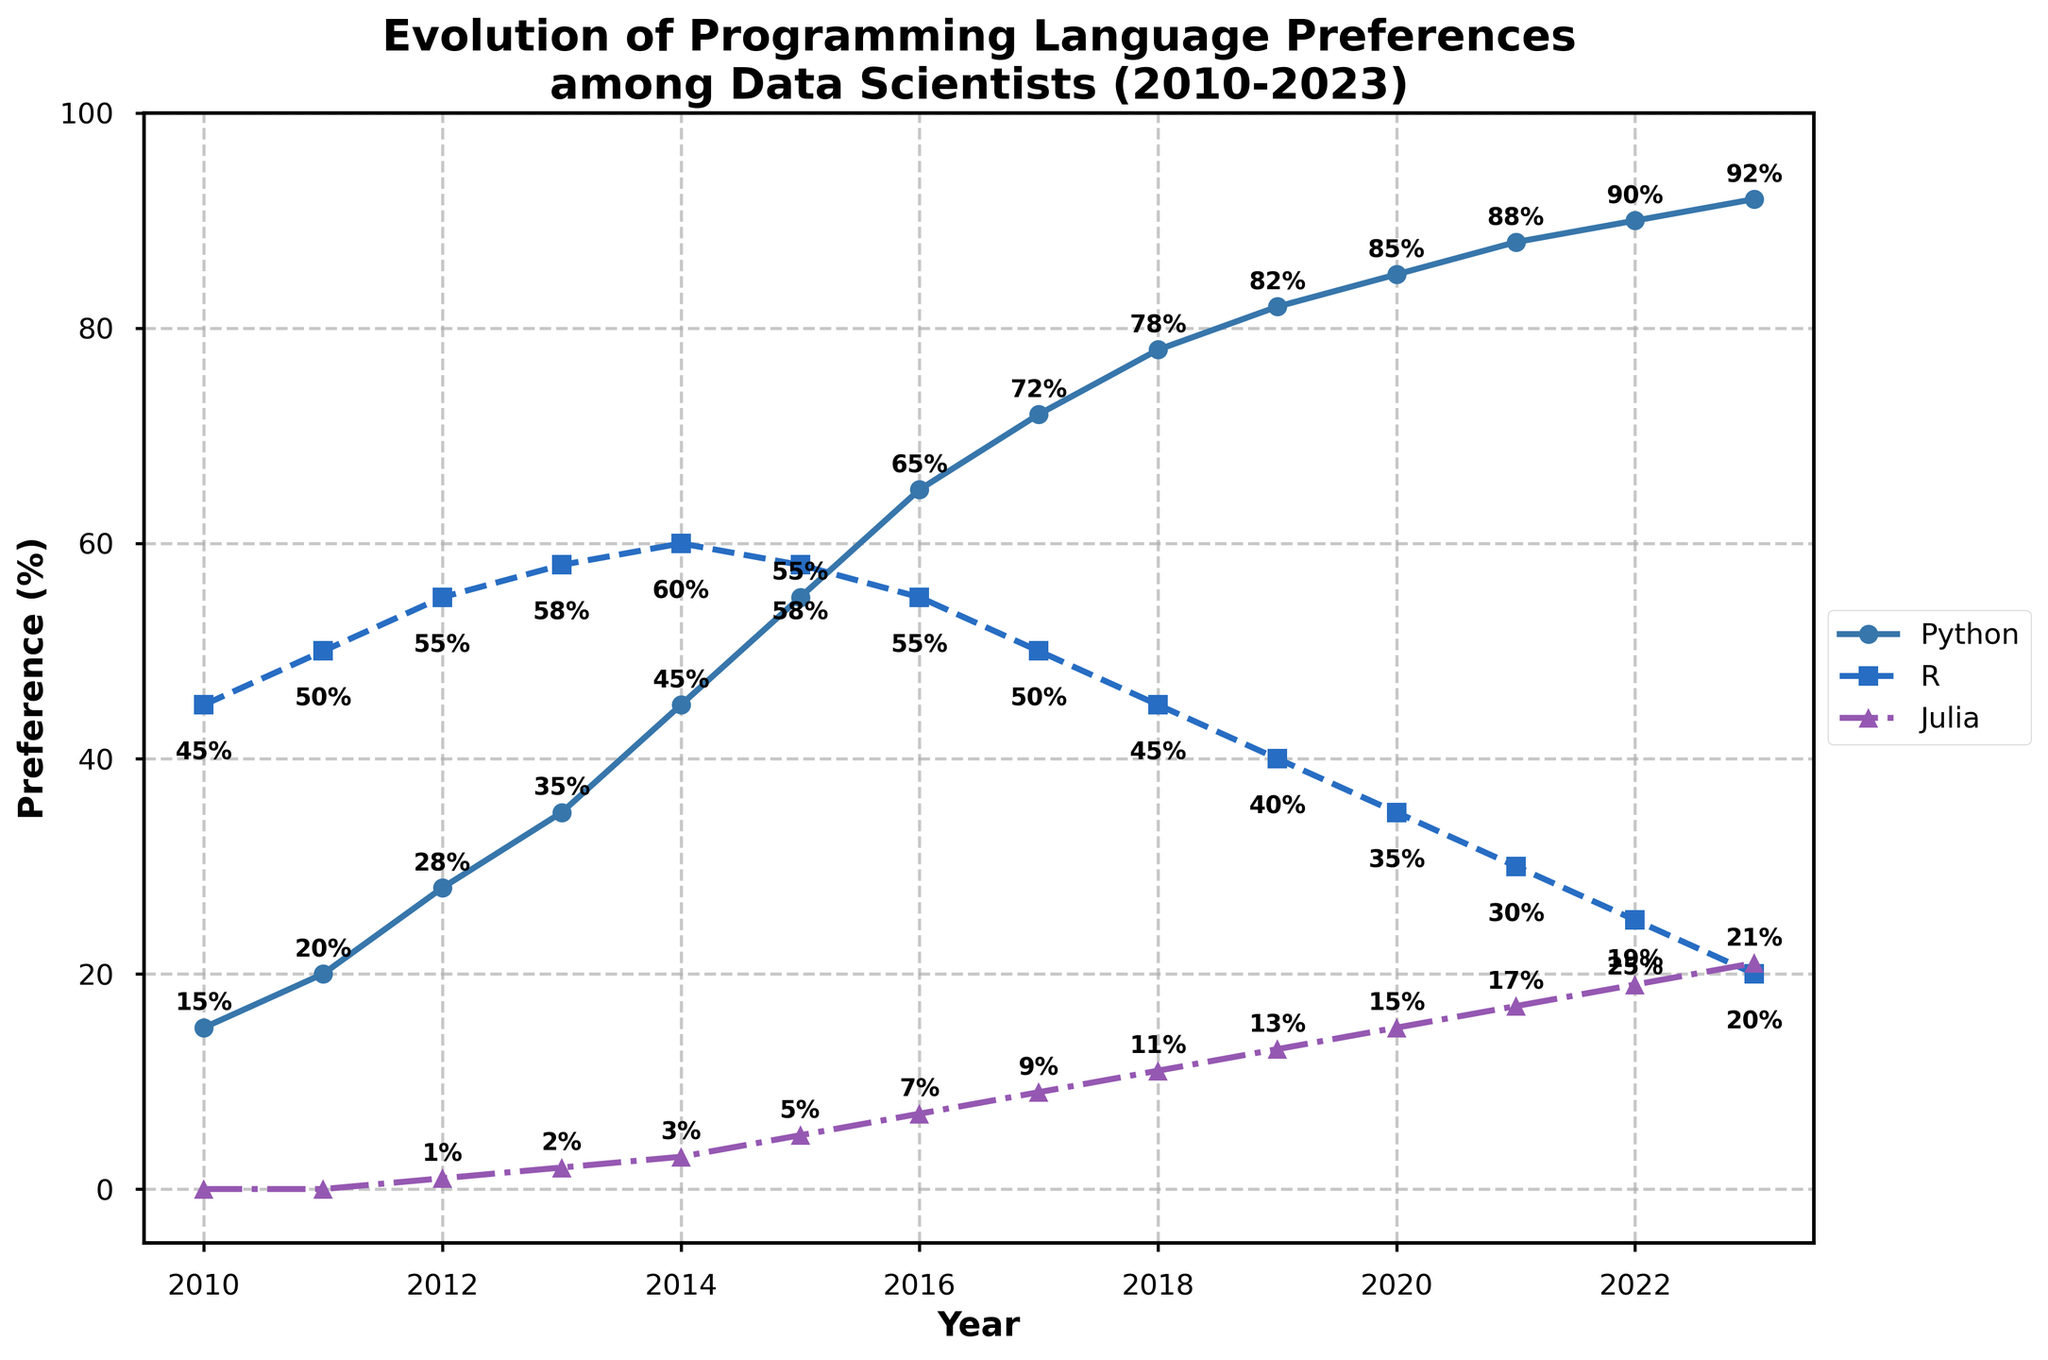What year did Python overtake R in preference among data scientists? According to the figure, Python overtakes R in preference between 2014 and 2015. The exact year when Python surpassed R would be 2015, as Python has a higher percentage than R in 2015.
Answer: 2015 What is the difference in preference percentage between Python and Julia in 2023? To find the difference in preference percentage between Python and Julia in 2023, subtract Julia's percentage from Python's percentage: 92% (Python) - 21% (Julia) = 71%.
Answer: 71% Identify the year when R starts to show a consistent decline in preference. From the figure, R shows a consistent decline starting from 2014 when it reaches its peak at 60% and drops each year afterward.
Answer: 2014 What is the average preference percentage of Python from 2010 to 2023? Sum the percentages of Python from 2010 to 2023 and divide by the number of years (14). Python percentages: [15, 20, 28, 35, 45, 55, 65, 72, 78, 82, 85, 88, 90, 92]. Sum = 850. Average = 850 / 14 ≈ 60.7.
Answer: 60.7 Did Julia ever surpass R in preference within the given time frame? If so, in which year? By examining the data, it is clear that Julia never surpassed R in preference from 2010 to 2023, as Julia's percentages remain much lower than R's throughout.
Answer: No What percentage did Python reach by 2018? Looking at the figure, Python's preference percentage in 2018 is 78%.
Answer: 78% Compare the initial and final percentages of R. How much did the preference for R decrease from 2010 to 2023? The preference for R in 2010 was 45%, and in 2023 it was 20%. The decrease is calculated as 45% - 20% = 25%.
Answer: 25% Which language shows an increasing trend in preference over the entire period? From the chart, Python and Julia show increasing trends in preference over the entire period from 2010 to 2023. Python starts at 15% and rises to 92%, and Julia starts from 0% to 21%.
Answer: Python and Julia What is the combined preference percentage of Python and R in 2020? To find the combined preference percentage of Python and R in 2020, add their respective percentages: 85% (Python) + 35% (R) = 120%.
Answer: 120% Which language had the sharpest increase in preference from 2010 to 2023? To determine the sharpest increase, compare the initial and final percentages of each language. Python increased from 15% to 92% (an increase of 77%), R decreased, and Julia increased from 0% to 21%. Python had the sharpest increase.
Answer: Python 